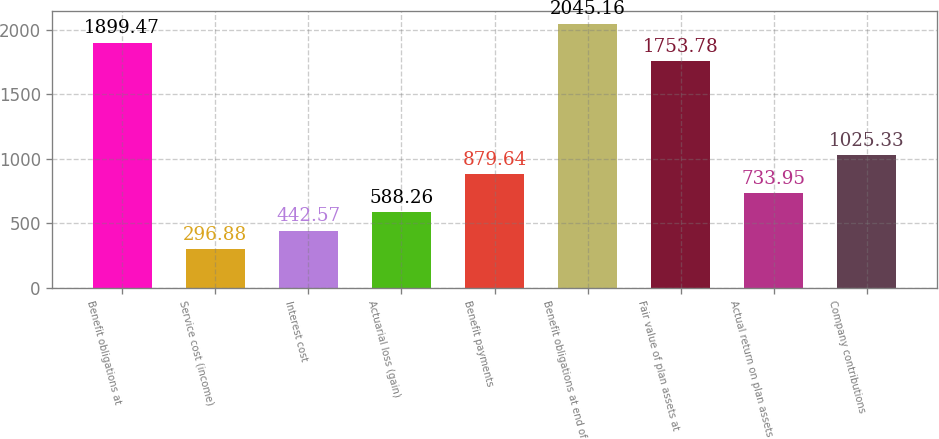Convert chart to OTSL. <chart><loc_0><loc_0><loc_500><loc_500><bar_chart><fcel>Benefit obligations at<fcel>Service cost (income)<fcel>Interest cost<fcel>Actuarial loss (gain)<fcel>Benefit payments<fcel>Benefit obligations at end of<fcel>Fair value of plan assets at<fcel>Actual return on plan assets<fcel>Company contributions<nl><fcel>1899.47<fcel>296.88<fcel>442.57<fcel>588.26<fcel>879.64<fcel>2045.16<fcel>1753.78<fcel>733.95<fcel>1025.33<nl></chart> 